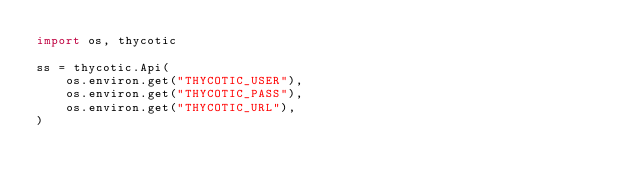<code> <loc_0><loc_0><loc_500><loc_500><_Python_>import os, thycotic

ss = thycotic.Api(
    os.environ.get("THYCOTIC_USER"),
    os.environ.get("THYCOTIC_PASS"),
    os.environ.get("THYCOTIC_URL"),
)
</code> 